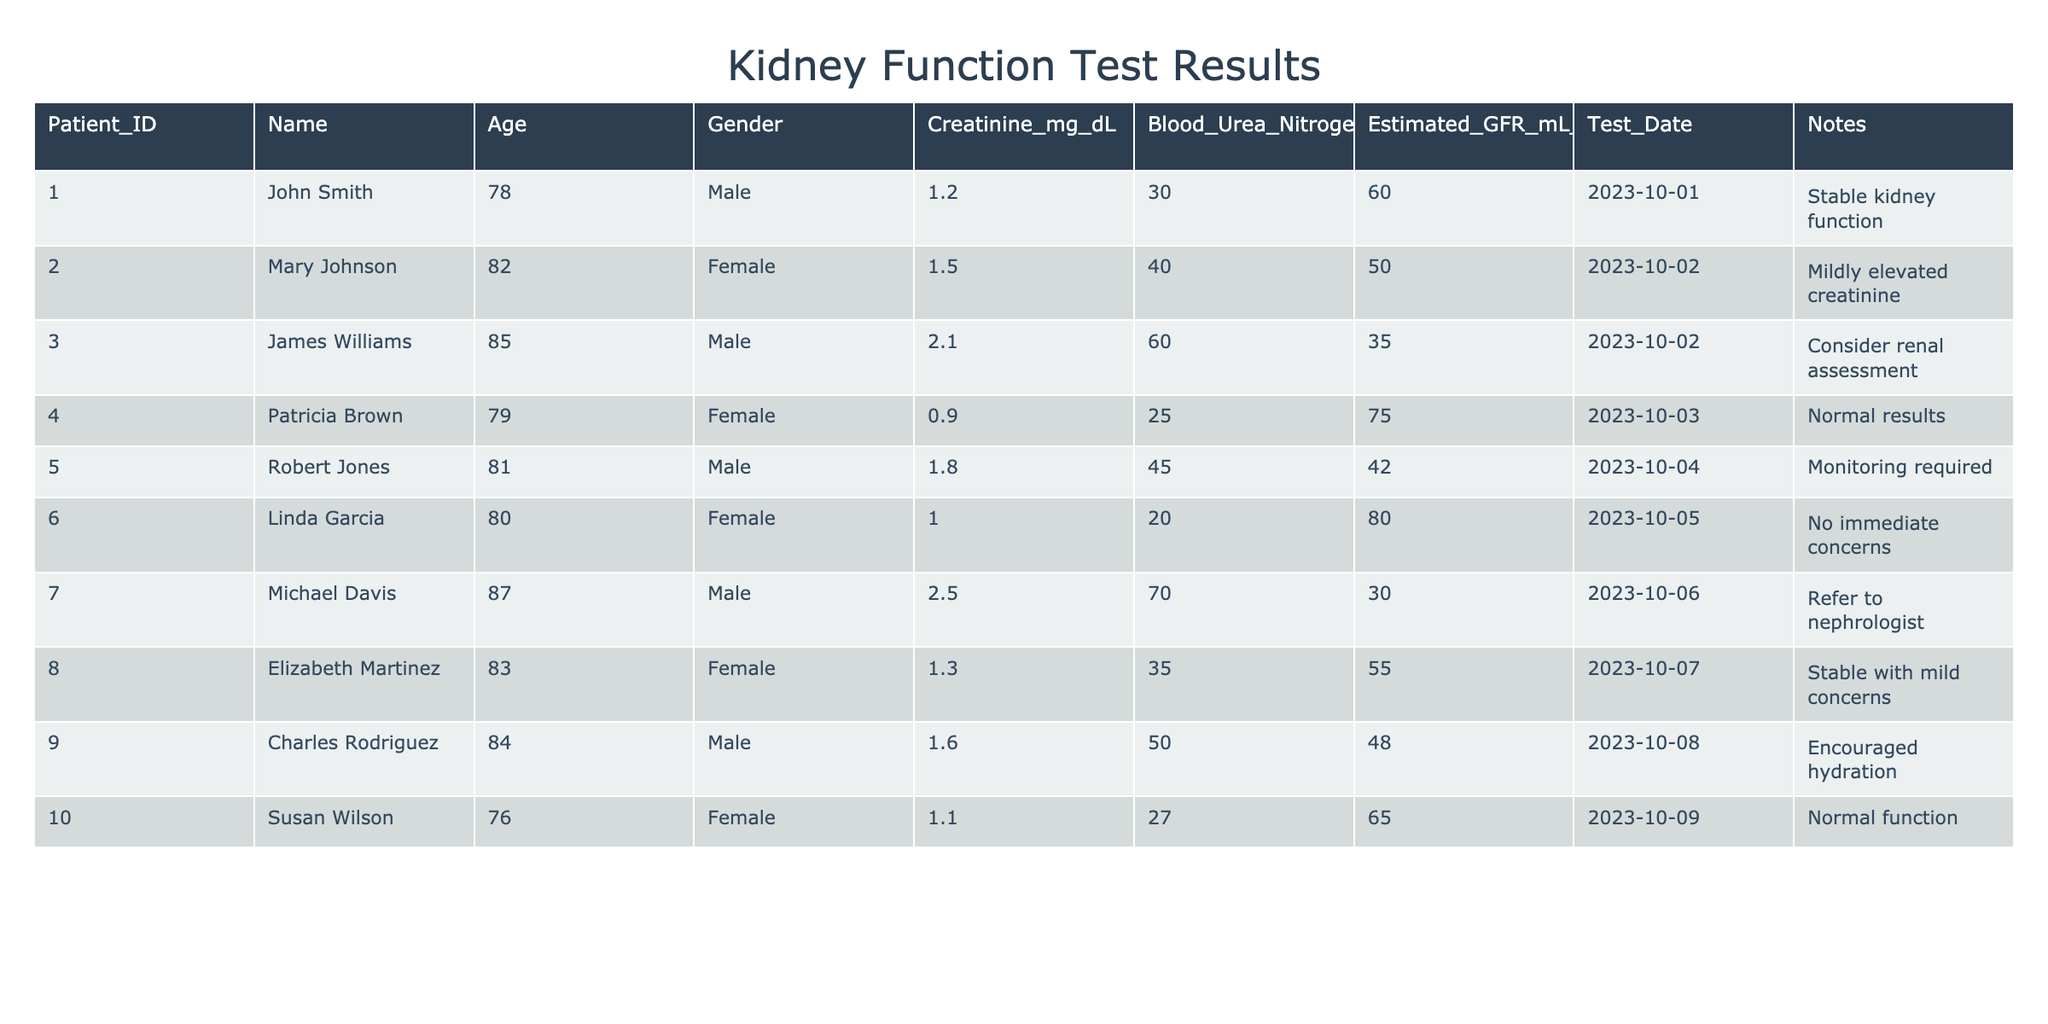What is the age of Michael Davis? From the table, I can directly locate Michael Davis's row and check the 'Age' column, which indicates he is 87 years old.
Answer: 87 Is Robert Jones's estimated GFR higher than the average of all patients? First, I need to calculate the average estimated GFR of all patients listed: (60 + 50 + 35 + 75 + 42 + 80 + 30 + 55 + 48 + 65) / 10 = 52.5. Then compare Robert Jones's GFR of 42 with the average. Since 42 is less than 52.5, the answer is no.
Answer: No Which patient has the highest creatinine level and what is that level? Looking through the 'Creatinine_mg_dL' column, I identify that Michael Davis has the highest level at 2.5 mg/dL.
Answer: Michael Davis, 2.5 How many patients have a creatinine level above 1.5 mg/dL? I review the 'Creatinine_mg_dL' column and count: James Williams (2.1), Robert Jones (1.8), and Michael Davis (2.5), which totals three patients.
Answer: 3 What is the difference between the highest and lowest blood urea nitrogen levels? The highest blood urea nitrogen level is 70 (Michael Davis) and the lowest is 20 (Linda Garcia). To find the difference, I subtract 20 from 70, which equals 50.
Answer: 50 Are all patients female? I look at the 'Gender' column and see both males (John Smith, James Williams, Robert Jones, Michael Davis, Charles Rodriguez) and females (Mary Johnson, Patricia Brown, Linda Garcia, Elizabeth Martinez, Susan Wilson) listed. Since there are males present, the answer is no.
Answer: No What percentage of the patients are male? There are 10 total patients, 5 of whom are male. So I calculate the percentage as (5/10) * 100, which equals 50%.
Answer: 50% Which patient has stable kidney function as per the notes? Checking the 'Notes' column, I identify that both John Smith and Elizabeth Martinez have 'Stable kidney function.'
Answer: John Smith, Elizabeth Martinez What is the average creatinine level of patients above 80 years old? The following seniors above 80 years old are James Williams (2.1), Michael Davis (2.5), and Linda Garcia (1.0). I sum these values: 2.1 + 2.5 + 1.0 = 5.6, and then divide by 3 patients: 5.6 / 3 = 1.87.
Answer: 1.87 